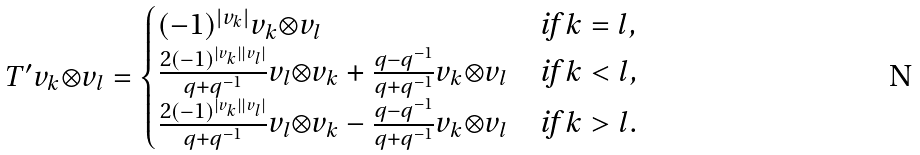Convert formula to latex. <formula><loc_0><loc_0><loc_500><loc_500>T ^ { \prime } v _ { k } { \otimes } v _ { l } = \begin{cases} ( - 1 ) ^ { | v _ { k } | } v _ { k } { \otimes } v _ { l } & \text {if $k=l$,} \\ \frac { 2 ( - 1 ) ^ { | v _ { k } | | v _ { l } | } } { q + q ^ { - 1 } } v _ { l } { \otimes } v _ { k } + \frac { q - q ^ { - 1 } } { q + q ^ { - 1 } } v _ { k } { \otimes } v _ { l } & \text {if $k<l$,} \\ \frac { 2 ( - 1 ) ^ { | v _ { k } | | v _ { l } | } } { q + q ^ { - 1 } } v _ { l } { \otimes } v _ { k } - \frac { q - q ^ { - 1 } } { q + q ^ { - 1 } } v _ { k } { \otimes } v _ { l } & \text {if $k>l$.} \end{cases}</formula> 